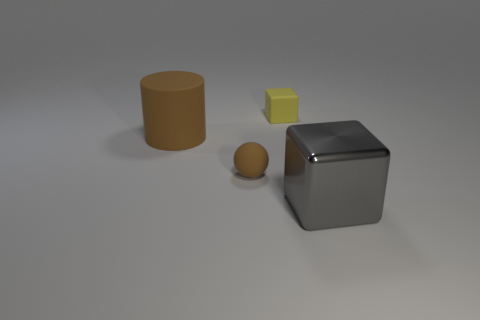Is there any other thing that has the same material as the big gray object?
Your answer should be very brief. No. Do the gray object and the object behind the large brown rubber thing have the same material?
Give a very brief answer. No. The thing that is the same size as the brown ball is what color?
Provide a succinct answer. Yellow. There is a brown matte object in front of the brown rubber object that is behind the matte sphere; what is its size?
Your answer should be compact. Small. Do the shiny cube and the block on the left side of the shiny block have the same color?
Your answer should be very brief. No. Is the number of big brown things behind the tiny rubber block less than the number of green metallic objects?
Make the answer very short. No. What number of other things are there of the same size as the matte cube?
Your answer should be very brief. 1. Do the big thing left of the metallic block and the tiny yellow rubber object have the same shape?
Your answer should be very brief. No. Are there more large brown cylinders that are in front of the brown rubber ball than big cyan cylinders?
Keep it short and to the point. No. What is the thing that is on the right side of the large brown cylinder and behind the small brown thing made of?
Give a very brief answer. Rubber. 